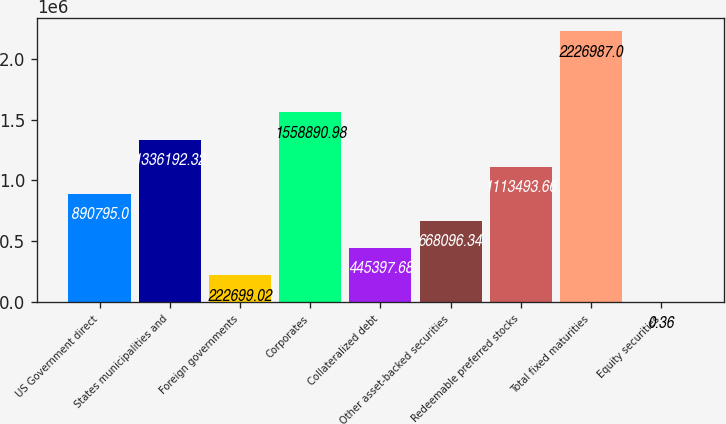<chart> <loc_0><loc_0><loc_500><loc_500><bar_chart><fcel>US Government direct<fcel>States municipalities and<fcel>Foreign governments<fcel>Corporates<fcel>Collateralized debt<fcel>Other asset-backed securities<fcel>Redeemable preferred stocks<fcel>Total fixed maturities<fcel>Equity securities<nl><fcel>890795<fcel>1.33619e+06<fcel>222699<fcel>1.55889e+06<fcel>445398<fcel>668096<fcel>1.11349e+06<fcel>2.22699e+06<fcel>0.36<nl></chart> 